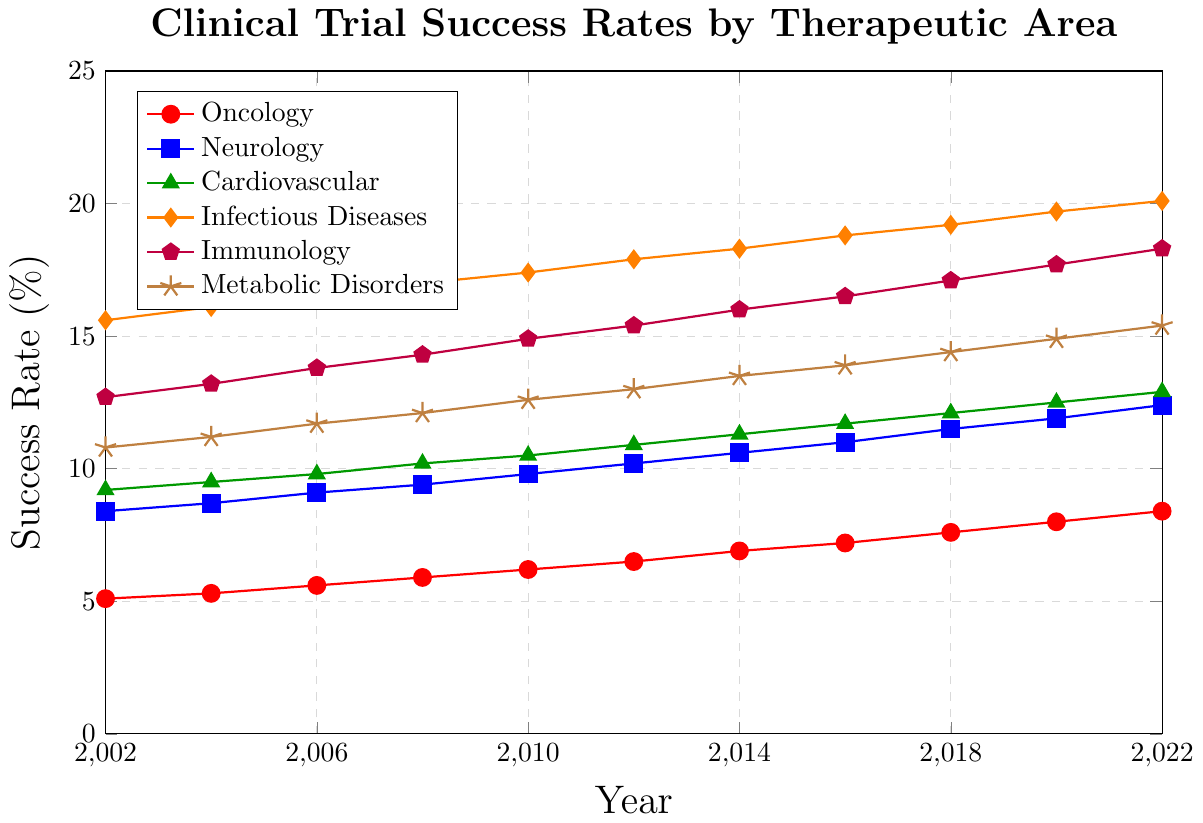What is the success rate of Oncology in 2022? Look for the Oncology line (red with circle markers) and identify the value at 2022.
Answer: 8.4% Which therapeutic area had the highest success rate in 2010? Check all the lines at the year 2010 and identify which one has the highest value.
Answer: Infectious Diseases By how much did the success rate for Neurology increase from 2002 to 2022? Subtract the success rate of Neurology in 2002 from its success rate in 2022 (12.4 - 8.4).
Answer: 4.0% Which therapeutic area showed the most consistent increase over the years? Compare the slopes of all lines to see which one shows a steady incline without significant fluctuations.
Answer: Oncology or Metabolic Disorders What is the average success rate for Cardiovascular from 2002 to 2022? Add the success rates for Cardiovascular over the years and divide by the number of data points (11). (9.2+9.5+9.8+10.2+10.5+10.9+11.3+11.7+12.1+12.5+12.9)/11.
Answer: 11.0% Which therapeutic area had the largest increase in success rate from 2002 to 2022? Calculate the increase for each therapeutic area by subtracting the 2002 value from the 2022 value and determine the largest one ((Oncology: 8.4-5.1, Neurology: 12.4-8.4, etc.)).
Answer: Infectious Diseases In what year did Immunology surpass a 15% success rate? Check the Immunology line (purple with pentagon markers) and identify the year when it first went above 15%.
Answer: 2014 Compare the success rates of Cardiovascular and Infectious Diseases in 2016. Which is higher and by how much? Identify the values for both in 2016 (Cardiovascular: 11.7, Infectious Diseases: 18.8) and subtract the smaller from the larger value (18.8 - 11.7).
Answer: Infectious Diseases by 7.1% What is the trend observed in the Metabolic Disorders success rate from 2002 to 2022? Observe the Metabolic Disorders line (brown with star markers) and describe its pattern of increase over the years.
Answer: Consistently increasing If the trend continues, what would be the approximate success rate for Oncology in 2024? Extrapolate the line for Oncology (red with circle markers) to 2024 based on its increasing trend from previous years.
Answer: Approximately 8.8% 